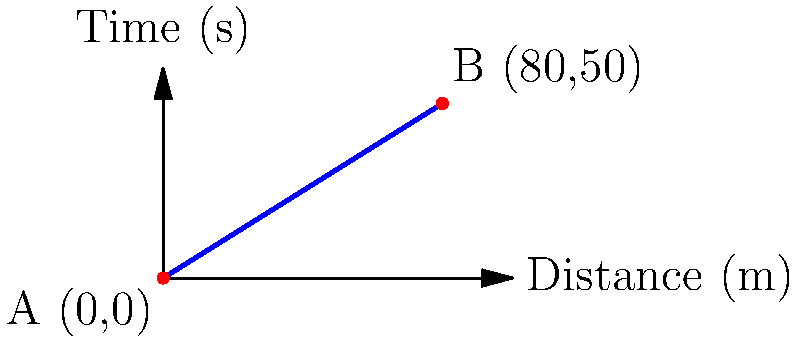In a crucial counterattack during a Scottish Championship match, a young talent on loan from an English Football League club sprints from point A (0,0) to point B (80,50) on the pitch. The x-axis represents the distance covered in meters, and the y-axis represents the time in seconds. Calculate the slope of the player's running path to analyze their acceleration during this counterattack. What does this slope represent in terms of the player's performance? To calculate the slope of the player's running path and analyze their acceleration, we'll follow these steps:

1) The slope formula is:
   $$m = \frac{y_2 - y_1}{x_2 - x_1}$$

2) We have two points:
   A (0,0) and B (80,50)
   So, $(x_1, y_1) = (0, 0)$ and $(x_2, y_2) = (80, 50)$

3) Let's substitute these values into the slope formula:
   $$m = \frac{50 - 0}{80 - 0} = \frac{50}{80}$$

4) Simplify the fraction:
   $$m = \frac{5}{8} = 0.625$$

5) Interpret the result:
   The slope represents the rate of change of time with respect to distance.
   In this context, it represents the inverse of the player's speed.

6) To get the player's speed, we need to take the reciprocal of the slope:
   $$\text{Speed} = \frac{1}{m} = \frac{1}{0.625} = 1.6 \text{ m/s}$$

7) Convert to km/h for a more familiar unit:
   $$1.6 \text{ m/s} \times \frac{3600 \text{ s}}{1 \text{ h}} \times \frac{1 \text{ km}}{1000 \text{ m}} = 5.76 \text{ km/h}$$

The slope of 0.625 represents the player's pace, which is the time taken per unit distance. The inverse of this (1.6 m/s or 5.76 km/h) represents the player's average speed during the counterattack. This relatively low speed suggests that the player may have been dribbling the ball or navigating through opponents, showcasing their technical skills rather than pure sprinting ability.
Answer: Slope = 0.625; represents player's pace (time/distance). Speed = 5.76 km/h, indicating tactical movement rather than full sprint. 